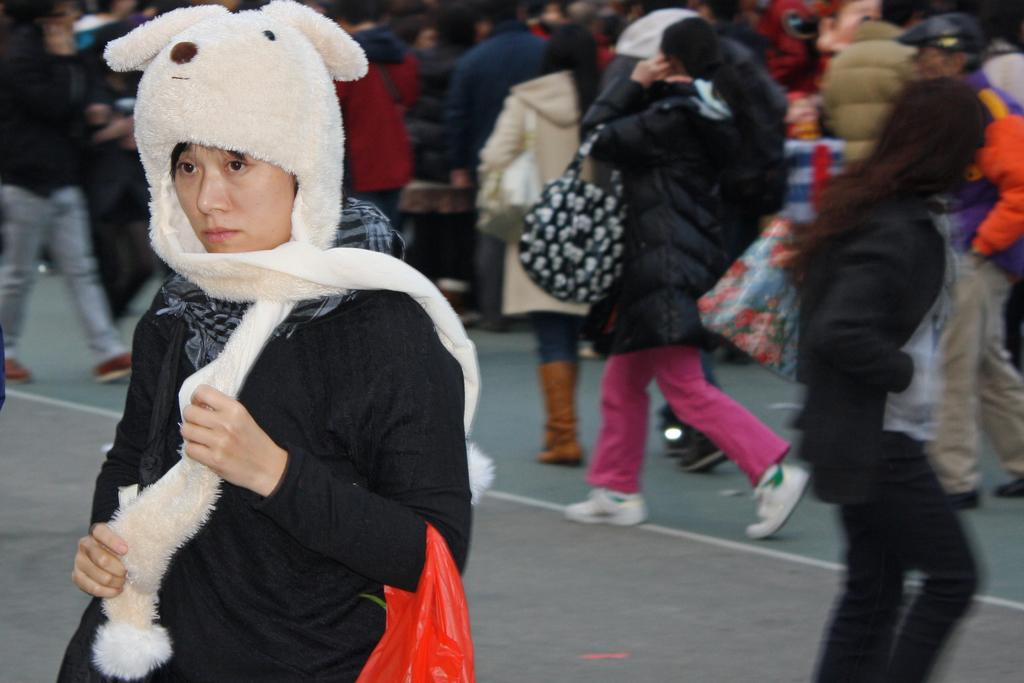Who or what can be seen in the image? There are people in the image. What are the people doing in the image? The people are walking on the road. What are the people carrying while walking on the road? The people are carrying bags. What else are the people holding in their hands? The people are holding objects in their hands. Where are the lizards hiding in the image? There are no lizards present in the image. What does the queen say to the people in the image? There is no queen present in the image, so it is not possible to answer this question. 